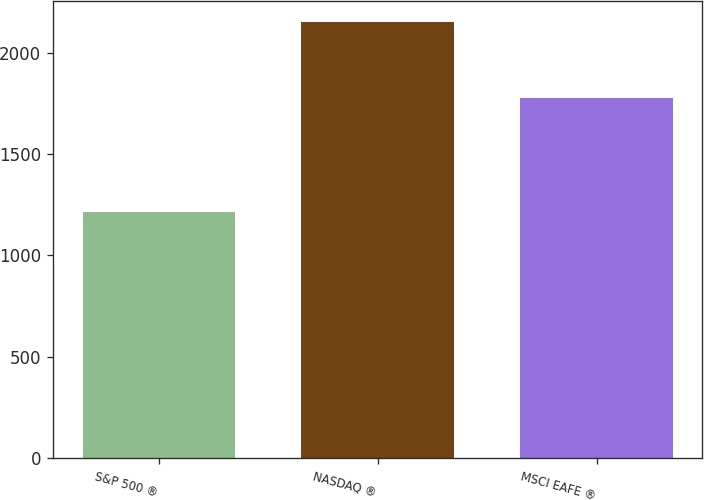Convert chart. <chart><loc_0><loc_0><loc_500><loc_500><bar_chart><fcel>S&P 500 ®<fcel>NASDAQ ®<fcel>MSCI EAFE ®<nl><fcel>1215<fcel>2149<fcel>1777<nl></chart> 